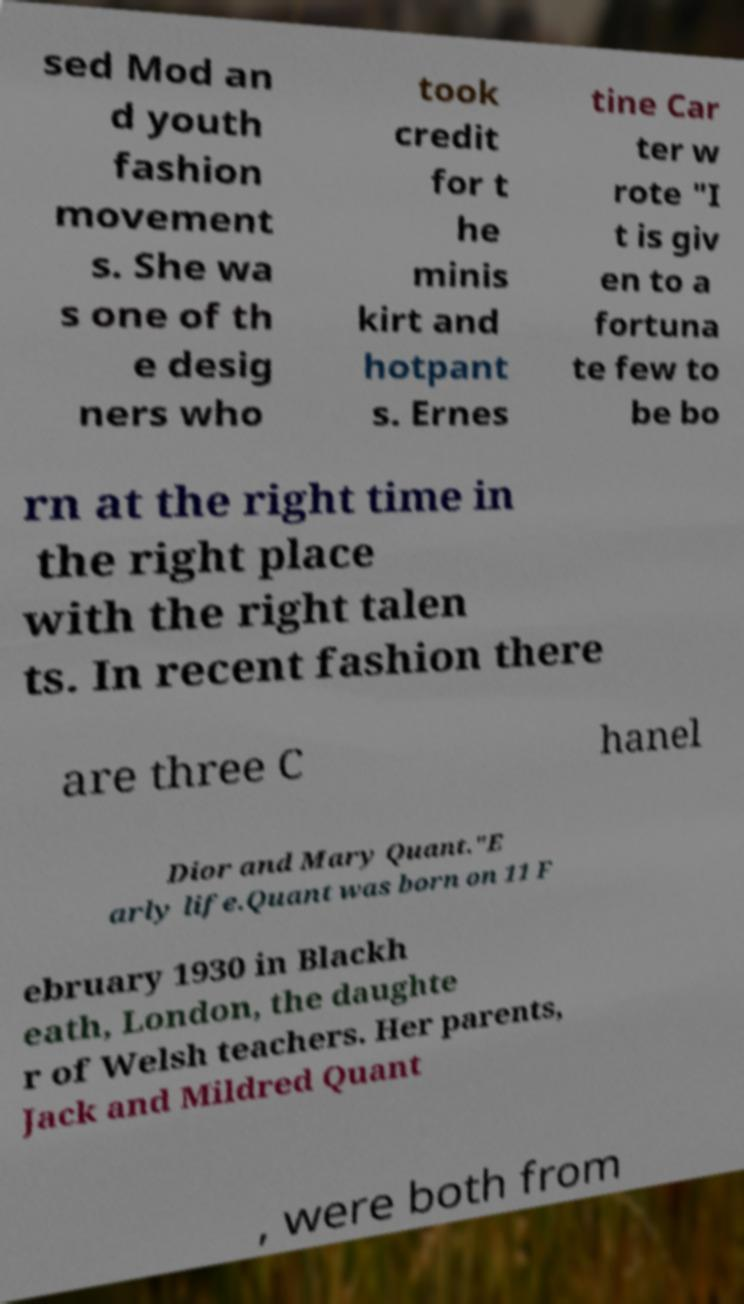Can you read and provide the text displayed in the image?This photo seems to have some interesting text. Can you extract and type it out for me? sed Mod an d youth fashion movement s. She wa s one of th e desig ners who took credit for t he minis kirt and hotpant s. Ernes tine Car ter w rote "I t is giv en to a fortuna te few to be bo rn at the right time in the right place with the right talen ts. In recent fashion there are three C hanel Dior and Mary Quant."E arly life.Quant was born on 11 F ebruary 1930 in Blackh eath, London, the daughte r of Welsh teachers. Her parents, Jack and Mildred Quant , were both from 